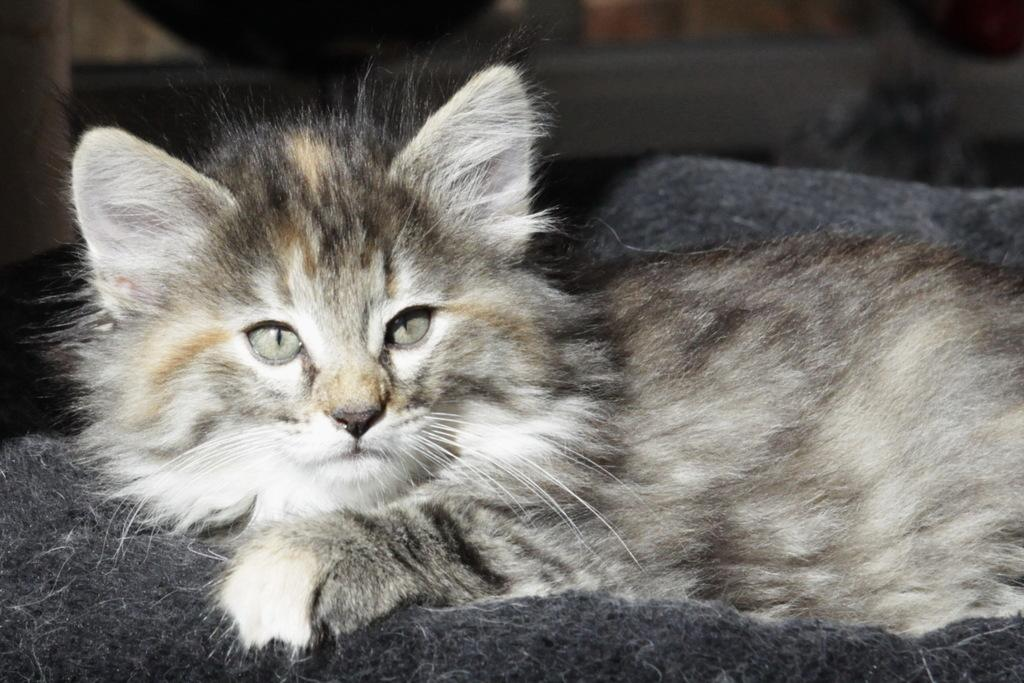What type of animal is in the image? There is a cat in the image. What is the cat standing or sitting on? The cat is on a black carpet. What type of religious symbol can be seen on the cat's collar in the image? There is no religious symbol or collar visible on the cat in the image. 